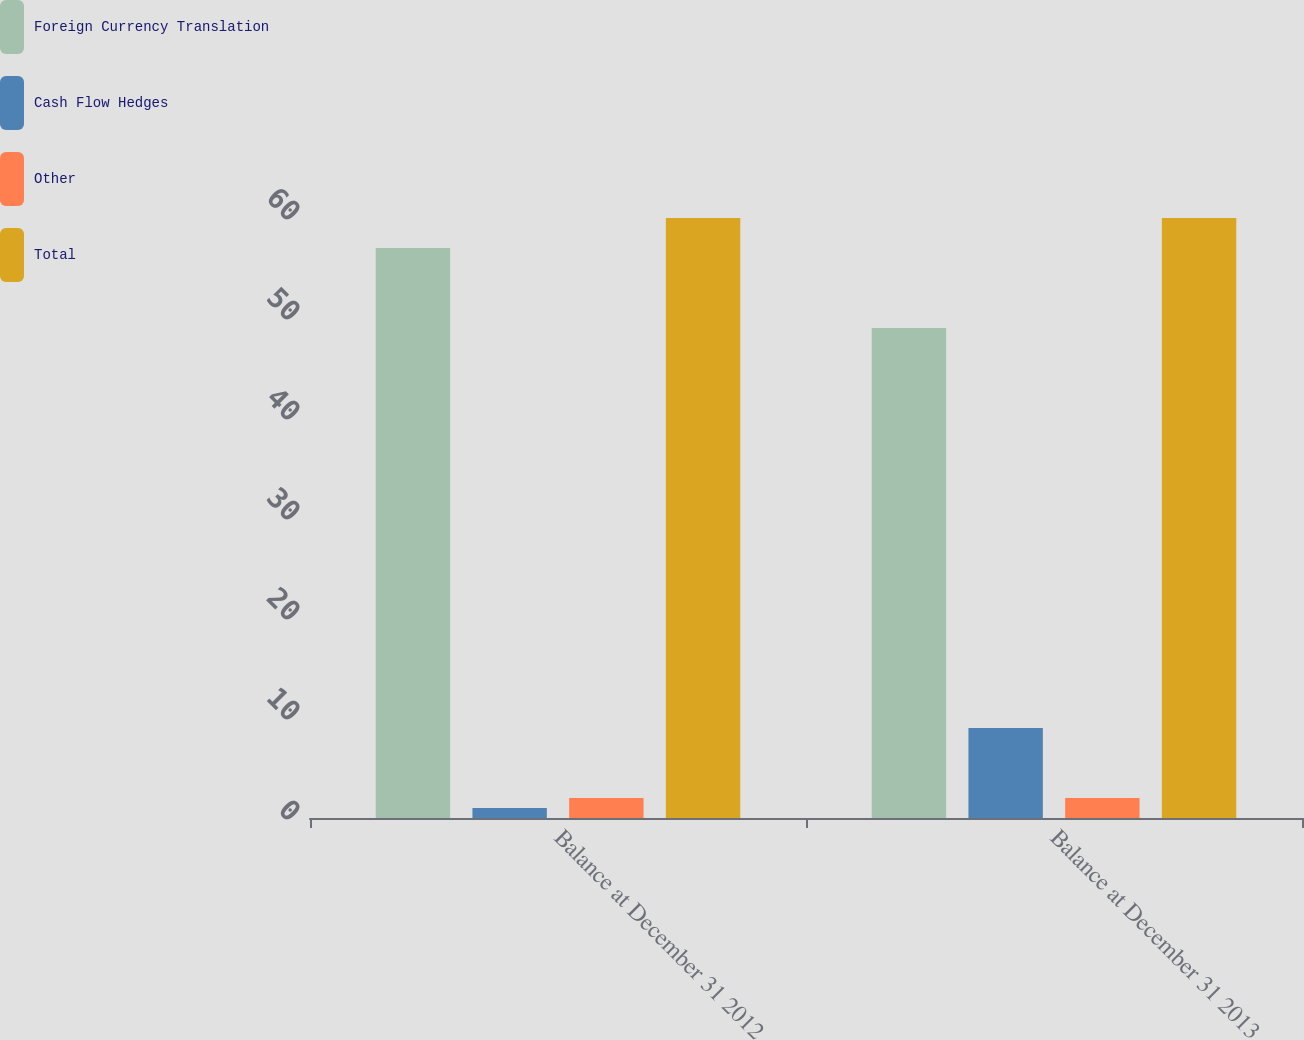<chart> <loc_0><loc_0><loc_500><loc_500><stacked_bar_chart><ecel><fcel>Balance at December 31 2012<fcel>Balance at December 31 2013<nl><fcel>Foreign Currency Translation<fcel>57<fcel>49<nl><fcel>Cash Flow Hedges<fcel>1<fcel>9<nl><fcel>Other<fcel>2<fcel>2<nl><fcel>Total<fcel>60<fcel>60<nl></chart> 